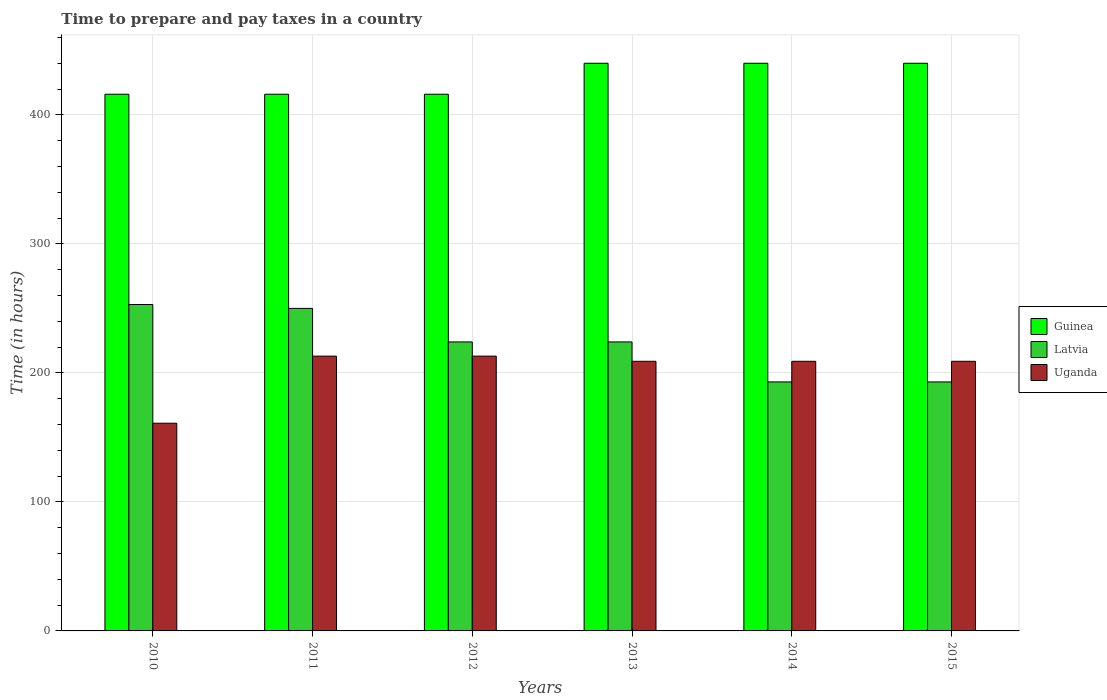Are the number of bars per tick equal to the number of legend labels?
Your response must be concise. Yes. Are the number of bars on each tick of the X-axis equal?
Provide a short and direct response. Yes. How many bars are there on the 2nd tick from the left?
Provide a succinct answer. 3. In how many cases, is the number of bars for a given year not equal to the number of legend labels?
Offer a very short reply. 0. What is the number of hours required to prepare and pay taxes in Guinea in 2012?
Keep it short and to the point. 416. Across all years, what is the maximum number of hours required to prepare and pay taxes in Uganda?
Your answer should be very brief. 213. Across all years, what is the minimum number of hours required to prepare and pay taxes in Latvia?
Ensure brevity in your answer.  193. In which year was the number of hours required to prepare and pay taxes in Guinea minimum?
Your answer should be very brief. 2010. What is the total number of hours required to prepare and pay taxes in Uganda in the graph?
Keep it short and to the point. 1214. What is the difference between the number of hours required to prepare and pay taxes in Latvia in 2013 and that in 2015?
Provide a succinct answer. 31. What is the difference between the number of hours required to prepare and pay taxes in Latvia in 2010 and the number of hours required to prepare and pay taxes in Guinea in 2013?
Your response must be concise. -187. What is the average number of hours required to prepare and pay taxes in Uganda per year?
Provide a short and direct response. 202.33. In the year 2014, what is the difference between the number of hours required to prepare and pay taxes in Uganda and number of hours required to prepare and pay taxes in Latvia?
Provide a succinct answer. 16. In how many years, is the number of hours required to prepare and pay taxes in Latvia greater than 420 hours?
Keep it short and to the point. 0. What is the ratio of the number of hours required to prepare and pay taxes in Guinea in 2011 to that in 2013?
Your answer should be very brief. 0.95. Is the number of hours required to prepare and pay taxes in Latvia in 2010 less than that in 2015?
Make the answer very short. No. What is the difference between the highest and the lowest number of hours required to prepare and pay taxes in Latvia?
Your answer should be compact. 60. What does the 1st bar from the left in 2014 represents?
Your answer should be compact. Guinea. What does the 3rd bar from the right in 2012 represents?
Offer a terse response. Guinea. Are all the bars in the graph horizontal?
Give a very brief answer. No. Does the graph contain grids?
Keep it short and to the point. Yes. How many legend labels are there?
Provide a short and direct response. 3. What is the title of the graph?
Give a very brief answer. Time to prepare and pay taxes in a country. Does "Cambodia" appear as one of the legend labels in the graph?
Provide a short and direct response. No. What is the label or title of the Y-axis?
Ensure brevity in your answer.  Time (in hours). What is the Time (in hours) in Guinea in 2010?
Keep it short and to the point. 416. What is the Time (in hours) of Latvia in 2010?
Ensure brevity in your answer.  253. What is the Time (in hours) of Uganda in 2010?
Offer a terse response. 161. What is the Time (in hours) of Guinea in 2011?
Give a very brief answer. 416. What is the Time (in hours) of Latvia in 2011?
Offer a very short reply. 250. What is the Time (in hours) in Uganda in 2011?
Offer a terse response. 213. What is the Time (in hours) of Guinea in 2012?
Keep it short and to the point. 416. What is the Time (in hours) in Latvia in 2012?
Provide a short and direct response. 224. What is the Time (in hours) of Uganda in 2012?
Your answer should be very brief. 213. What is the Time (in hours) of Guinea in 2013?
Provide a short and direct response. 440. What is the Time (in hours) in Latvia in 2013?
Your answer should be compact. 224. What is the Time (in hours) of Uganda in 2013?
Your response must be concise. 209. What is the Time (in hours) of Guinea in 2014?
Your response must be concise. 440. What is the Time (in hours) of Latvia in 2014?
Give a very brief answer. 193. What is the Time (in hours) in Uganda in 2014?
Offer a terse response. 209. What is the Time (in hours) in Guinea in 2015?
Your answer should be very brief. 440. What is the Time (in hours) in Latvia in 2015?
Your response must be concise. 193. What is the Time (in hours) in Uganda in 2015?
Make the answer very short. 209. Across all years, what is the maximum Time (in hours) in Guinea?
Your response must be concise. 440. Across all years, what is the maximum Time (in hours) of Latvia?
Offer a terse response. 253. Across all years, what is the maximum Time (in hours) of Uganda?
Offer a terse response. 213. Across all years, what is the minimum Time (in hours) in Guinea?
Keep it short and to the point. 416. Across all years, what is the minimum Time (in hours) of Latvia?
Keep it short and to the point. 193. Across all years, what is the minimum Time (in hours) in Uganda?
Your answer should be compact. 161. What is the total Time (in hours) in Guinea in the graph?
Your answer should be very brief. 2568. What is the total Time (in hours) of Latvia in the graph?
Keep it short and to the point. 1337. What is the total Time (in hours) in Uganda in the graph?
Make the answer very short. 1214. What is the difference between the Time (in hours) in Guinea in 2010 and that in 2011?
Ensure brevity in your answer.  0. What is the difference between the Time (in hours) of Latvia in 2010 and that in 2011?
Keep it short and to the point. 3. What is the difference between the Time (in hours) in Uganda in 2010 and that in 2011?
Provide a succinct answer. -52. What is the difference between the Time (in hours) in Latvia in 2010 and that in 2012?
Provide a succinct answer. 29. What is the difference between the Time (in hours) of Uganda in 2010 and that in 2012?
Your response must be concise. -52. What is the difference between the Time (in hours) of Uganda in 2010 and that in 2013?
Offer a terse response. -48. What is the difference between the Time (in hours) of Uganda in 2010 and that in 2014?
Provide a succinct answer. -48. What is the difference between the Time (in hours) of Uganda in 2010 and that in 2015?
Give a very brief answer. -48. What is the difference between the Time (in hours) of Guinea in 2011 and that in 2012?
Your answer should be compact. 0. What is the difference between the Time (in hours) in Latvia in 2011 and that in 2012?
Provide a short and direct response. 26. What is the difference between the Time (in hours) of Latvia in 2011 and that in 2013?
Make the answer very short. 26. What is the difference between the Time (in hours) in Uganda in 2011 and that in 2013?
Your answer should be compact. 4. What is the difference between the Time (in hours) in Uganda in 2011 and that in 2014?
Offer a very short reply. 4. What is the difference between the Time (in hours) of Latvia in 2011 and that in 2015?
Provide a short and direct response. 57. What is the difference between the Time (in hours) of Guinea in 2012 and that in 2013?
Provide a succinct answer. -24. What is the difference between the Time (in hours) of Uganda in 2012 and that in 2013?
Your answer should be very brief. 4. What is the difference between the Time (in hours) of Guinea in 2012 and that in 2015?
Provide a succinct answer. -24. What is the difference between the Time (in hours) of Guinea in 2013 and that in 2014?
Offer a terse response. 0. What is the difference between the Time (in hours) of Latvia in 2013 and that in 2014?
Make the answer very short. 31. What is the difference between the Time (in hours) of Latvia in 2013 and that in 2015?
Your answer should be very brief. 31. What is the difference between the Time (in hours) of Uganda in 2013 and that in 2015?
Offer a terse response. 0. What is the difference between the Time (in hours) in Uganda in 2014 and that in 2015?
Keep it short and to the point. 0. What is the difference between the Time (in hours) in Guinea in 2010 and the Time (in hours) in Latvia in 2011?
Ensure brevity in your answer.  166. What is the difference between the Time (in hours) in Guinea in 2010 and the Time (in hours) in Uganda in 2011?
Offer a very short reply. 203. What is the difference between the Time (in hours) in Guinea in 2010 and the Time (in hours) in Latvia in 2012?
Ensure brevity in your answer.  192. What is the difference between the Time (in hours) of Guinea in 2010 and the Time (in hours) of Uganda in 2012?
Give a very brief answer. 203. What is the difference between the Time (in hours) of Latvia in 2010 and the Time (in hours) of Uganda in 2012?
Offer a very short reply. 40. What is the difference between the Time (in hours) in Guinea in 2010 and the Time (in hours) in Latvia in 2013?
Ensure brevity in your answer.  192. What is the difference between the Time (in hours) in Guinea in 2010 and the Time (in hours) in Uganda in 2013?
Give a very brief answer. 207. What is the difference between the Time (in hours) in Latvia in 2010 and the Time (in hours) in Uganda in 2013?
Offer a terse response. 44. What is the difference between the Time (in hours) of Guinea in 2010 and the Time (in hours) of Latvia in 2014?
Give a very brief answer. 223. What is the difference between the Time (in hours) of Guinea in 2010 and the Time (in hours) of Uganda in 2014?
Provide a succinct answer. 207. What is the difference between the Time (in hours) in Guinea in 2010 and the Time (in hours) in Latvia in 2015?
Provide a succinct answer. 223. What is the difference between the Time (in hours) of Guinea in 2010 and the Time (in hours) of Uganda in 2015?
Keep it short and to the point. 207. What is the difference between the Time (in hours) in Latvia in 2010 and the Time (in hours) in Uganda in 2015?
Provide a short and direct response. 44. What is the difference between the Time (in hours) of Guinea in 2011 and the Time (in hours) of Latvia in 2012?
Your response must be concise. 192. What is the difference between the Time (in hours) in Guinea in 2011 and the Time (in hours) in Uganda in 2012?
Your answer should be very brief. 203. What is the difference between the Time (in hours) in Latvia in 2011 and the Time (in hours) in Uganda in 2012?
Offer a very short reply. 37. What is the difference between the Time (in hours) in Guinea in 2011 and the Time (in hours) in Latvia in 2013?
Provide a short and direct response. 192. What is the difference between the Time (in hours) in Guinea in 2011 and the Time (in hours) in Uganda in 2013?
Your answer should be very brief. 207. What is the difference between the Time (in hours) of Guinea in 2011 and the Time (in hours) of Latvia in 2014?
Your answer should be very brief. 223. What is the difference between the Time (in hours) of Guinea in 2011 and the Time (in hours) of Uganda in 2014?
Make the answer very short. 207. What is the difference between the Time (in hours) of Latvia in 2011 and the Time (in hours) of Uganda in 2014?
Ensure brevity in your answer.  41. What is the difference between the Time (in hours) of Guinea in 2011 and the Time (in hours) of Latvia in 2015?
Make the answer very short. 223. What is the difference between the Time (in hours) in Guinea in 2011 and the Time (in hours) in Uganda in 2015?
Your answer should be very brief. 207. What is the difference between the Time (in hours) of Guinea in 2012 and the Time (in hours) of Latvia in 2013?
Make the answer very short. 192. What is the difference between the Time (in hours) of Guinea in 2012 and the Time (in hours) of Uganda in 2013?
Keep it short and to the point. 207. What is the difference between the Time (in hours) of Guinea in 2012 and the Time (in hours) of Latvia in 2014?
Your answer should be compact. 223. What is the difference between the Time (in hours) in Guinea in 2012 and the Time (in hours) in Uganda in 2014?
Make the answer very short. 207. What is the difference between the Time (in hours) of Latvia in 2012 and the Time (in hours) of Uganda in 2014?
Provide a short and direct response. 15. What is the difference between the Time (in hours) in Guinea in 2012 and the Time (in hours) in Latvia in 2015?
Your response must be concise. 223. What is the difference between the Time (in hours) in Guinea in 2012 and the Time (in hours) in Uganda in 2015?
Your answer should be very brief. 207. What is the difference between the Time (in hours) in Guinea in 2013 and the Time (in hours) in Latvia in 2014?
Keep it short and to the point. 247. What is the difference between the Time (in hours) of Guinea in 2013 and the Time (in hours) of Uganda in 2014?
Make the answer very short. 231. What is the difference between the Time (in hours) of Latvia in 2013 and the Time (in hours) of Uganda in 2014?
Offer a terse response. 15. What is the difference between the Time (in hours) in Guinea in 2013 and the Time (in hours) in Latvia in 2015?
Provide a short and direct response. 247. What is the difference between the Time (in hours) in Guinea in 2013 and the Time (in hours) in Uganda in 2015?
Provide a succinct answer. 231. What is the difference between the Time (in hours) of Guinea in 2014 and the Time (in hours) of Latvia in 2015?
Your answer should be compact. 247. What is the difference between the Time (in hours) in Guinea in 2014 and the Time (in hours) in Uganda in 2015?
Make the answer very short. 231. What is the difference between the Time (in hours) in Latvia in 2014 and the Time (in hours) in Uganda in 2015?
Give a very brief answer. -16. What is the average Time (in hours) of Guinea per year?
Offer a very short reply. 428. What is the average Time (in hours) in Latvia per year?
Offer a very short reply. 222.83. What is the average Time (in hours) of Uganda per year?
Your answer should be very brief. 202.33. In the year 2010, what is the difference between the Time (in hours) of Guinea and Time (in hours) of Latvia?
Make the answer very short. 163. In the year 2010, what is the difference between the Time (in hours) in Guinea and Time (in hours) in Uganda?
Provide a succinct answer. 255. In the year 2010, what is the difference between the Time (in hours) in Latvia and Time (in hours) in Uganda?
Offer a very short reply. 92. In the year 2011, what is the difference between the Time (in hours) in Guinea and Time (in hours) in Latvia?
Offer a very short reply. 166. In the year 2011, what is the difference between the Time (in hours) in Guinea and Time (in hours) in Uganda?
Offer a terse response. 203. In the year 2012, what is the difference between the Time (in hours) of Guinea and Time (in hours) of Latvia?
Your answer should be very brief. 192. In the year 2012, what is the difference between the Time (in hours) of Guinea and Time (in hours) of Uganda?
Offer a very short reply. 203. In the year 2012, what is the difference between the Time (in hours) of Latvia and Time (in hours) of Uganda?
Provide a short and direct response. 11. In the year 2013, what is the difference between the Time (in hours) of Guinea and Time (in hours) of Latvia?
Make the answer very short. 216. In the year 2013, what is the difference between the Time (in hours) of Guinea and Time (in hours) of Uganda?
Offer a very short reply. 231. In the year 2013, what is the difference between the Time (in hours) in Latvia and Time (in hours) in Uganda?
Your answer should be very brief. 15. In the year 2014, what is the difference between the Time (in hours) of Guinea and Time (in hours) of Latvia?
Your response must be concise. 247. In the year 2014, what is the difference between the Time (in hours) in Guinea and Time (in hours) in Uganda?
Ensure brevity in your answer.  231. In the year 2015, what is the difference between the Time (in hours) in Guinea and Time (in hours) in Latvia?
Offer a very short reply. 247. In the year 2015, what is the difference between the Time (in hours) of Guinea and Time (in hours) of Uganda?
Provide a short and direct response. 231. In the year 2015, what is the difference between the Time (in hours) of Latvia and Time (in hours) of Uganda?
Give a very brief answer. -16. What is the ratio of the Time (in hours) in Uganda in 2010 to that in 2011?
Offer a terse response. 0.76. What is the ratio of the Time (in hours) of Latvia in 2010 to that in 2012?
Provide a succinct answer. 1.13. What is the ratio of the Time (in hours) of Uganda in 2010 to that in 2012?
Your answer should be compact. 0.76. What is the ratio of the Time (in hours) of Guinea in 2010 to that in 2013?
Ensure brevity in your answer.  0.95. What is the ratio of the Time (in hours) of Latvia in 2010 to that in 2013?
Provide a succinct answer. 1.13. What is the ratio of the Time (in hours) in Uganda in 2010 to that in 2013?
Offer a terse response. 0.77. What is the ratio of the Time (in hours) in Guinea in 2010 to that in 2014?
Offer a terse response. 0.95. What is the ratio of the Time (in hours) in Latvia in 2010 to that in 2014?
Make the answer very short. 1.31. What is the ratio of the Time (in hours) of Uganda in 2010 to that in 2014?
Offer a terse response. 0.77. What is the ratio of the Time (in hours) of Guinea in 2010 to that in 2015?
Provide a succinct answer. 0.95. What is the ratio of the Time (in hours) in Latvia in 2010 to that in 2015?
Ensure brevity in your answer.  1.31. What is the ratio of the Time (in hours) in Uganda in 2010 to that in 2015?
Provide a short and direct response. 0.77. What is the ratio of the Time (in hours) in Latvia in 2011 to that in 2012?
Provide a short and direct response. 1.12. What is the ratio of the Time (in hours) in Uganda in 2011 to that in 2012?
Offer a terse response. 1. What is the ratio of the Time (in hours) in Guinea in 2011 to that in 2013?
Keep it short and to the point. 0.95. What is the ratio of the Time (in hours) in Latvia in 2011 to that in 2013?
Your response must be concise. 1.12. What is the ratio of the Time (in hours) of Uganda in 2011 to that in 2013?
Your response must be concise. 1.02. What is the ratio of the Time (in hours) of Guinea in 2011 to that in 2014?
Keep it short and to the point. 0.95. What is the ratio of the Time (in hours) in Latvia in 2011 to that in 2014?
Make the answer very short. 1.3. What is the ratio of the Time (in hours) in Uganda in 2011 to that in 2014?
Ensure brevity in your answer.  1.02. What is the ratio of the Time (in hours) of Guinea in 2011 to that in 2015?
Your answer should be compact. 0.95. What is the ratio of the Time (in hours) in Latvia in 2011 to that in 2015?
Make the answer very short. 1.3. What is the ratio of the Time (in hours) in Uganda in 2011 to that in 2015?
Give a very brief answer. 1.02. What is the ratio of the Time (in hours) of Guinea in 2012 to that in 2013?
Your answer should be compact. 0.95. What is the ratio of the Time (in hours) of Uganda in 2012 to that in 2013?
Offer a very short reply. 1.02. What is the ratio of the Time (in hours) in Guinea in 2012 to that in 2014?
Your answer should be compact. 0.95. What is the ratio of the Time (in hours) in Latvia in 2012 to that in 2014?
Your answer should be very brief. 1.16. What is the ratio of the Time (in hours) of Uganda in 2012 to that in 2014?
Offer a terse response. 1.02. What is the ratio of the Time (in hours) of Guinea in 2012 to that in 2015?
Keep it short and to the point. 0.95. What is the ratio of the Time (in hours) in Latvia in 2012 to that in 2015?
Ensure brevity in your answer.  1.16. What is the ratio of the Time (in hours) of Uganda in 2012 to that in 2015?
Your answer should be compact. 1.02. What is the ratio of the Time (in hours) of Guinea in 2013 to that in 2014?
Offer a terse response. 1. What is the ratio of the Time (in hours) in Latvia in 2013 to that in 2014?
Your response must be concise. 1.16. What is the ratio of the Time (in hours) of Guinea in 2013 to that in 2015?
Ensure brevity in your answer.  1. What is the ratio of the Time (in hours) in Latvia in 2013 to that in 2015?
Your answer should be very brief. 1.16. What is the ratio of the Time (in hours) of Uganda in 2013 to that in 2015?
Give a very brief answer. 1. What is the ratio of the Time (in hours) of Guinea in 2014 to that in 2015?
Give a very brief answer. 1. What is the ratio of the Time (in hours) of Latvia in 2014 to that in 2015?
Offer a terse response. 1. What is the difference between the highest and the second highest Time (in hours) of Latvia?
Ensure brevity in your answer.  3. What is the difference between the highest and the lowest Time (in hours) of Guinea?
Give a very brief answer. 24. What is the difference between the highest and the lowest Time (in hours) of Latvia?
Offer a very short reply. 60. 